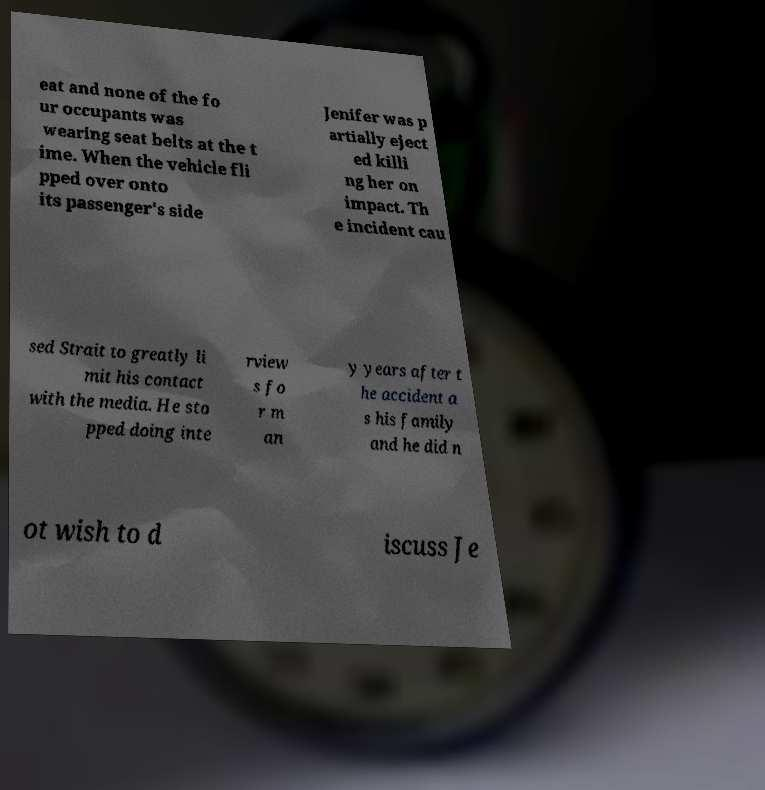Can you read and provide the text displayed in the image?This photo seems to have some interesting text. Can you extract and type it out for me? eat and none of the fo ur occupants was wearing seat belts at the t ime. When the vehicle fli pped over onto its passenger's side Jenifer was p artially eject ed killi ng her on impact. Th e incident cau sed Strait to greatly li mit his contact with the media. He sto pped doing inte rview s fo r m an y years after t he accident a s his family and he did n ot wish to d iscuss Je 